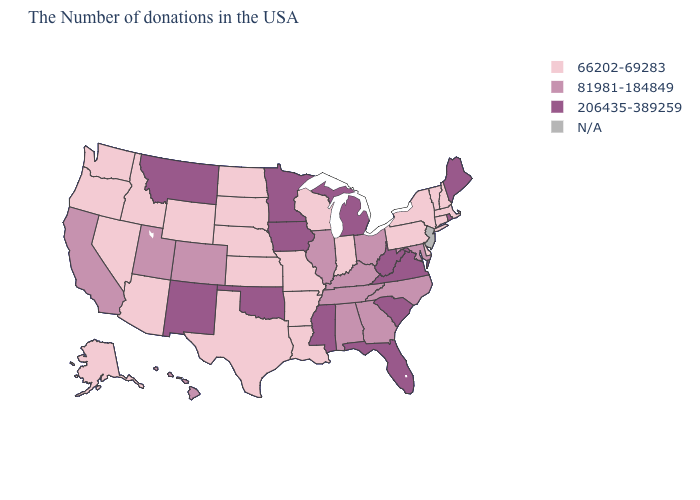Among the states that border Pennsylvania , does Ohio have the highest value?
Keep it brief. No. What is the lowest value in the USA?
Give a very brief answer. 66202-69283. What is the value of Michigan?
Answer briefly. 206435-389259. What is the value of Colorado?
Keep it brief. 81981-184849. Does Maryland have the lowest value in the South?
Write a very short answer. No. Name the states that have a value in the range 66202-69283?
Quick response, please. Massachusetts, New Hampshire, Vermont, Connecticut, New York, Delaware, Pennsylvania, Indiana, Wisconsin, Louisiana, Missouri, Arkansas, Kansas, Nebraska, Texas, South Dakota, North Dakota, Wyoming, Arizona, Idaho, Nevada, Washington, Oregon, Alaska. What is the value of Pennsylvania?
Write a very short answer. 66202-69283. Among the states that border North Carolina , does Tennessee have the highest value?
Short answer required. No. What is the lowest value in states that border New York?
Keep it brief. 66202-69283. Name the states that have a value in the range 206435-389259?
Keep it brief. Maine, Rhode Island, Virginia, South Carolina, West Virginia, Florida, Michigan, Mississippi, Minnesota, Iowa, Oklahoma, New Mexico, Montana. Name the states that have a value in the range 206435-389259?
Be succinct. Maine, Rhode Island, Virginia, South Carolina, West Virginia, Florida, Michigan, Mississippi, Minnesota, Iowa, Oklahoma, New Mexico, Montana. Does the first symbol in the legend represent the smallest category?
Write a very short answer. Yes. Name the states that have a value in the range 206435-389259?
Write a very short answer. Maine, Rhode Island, Virginia, South Carolina, West Virginia, Florida, Michigan, Mississippi, Minnesota, Iowa, Oklahoma, New Mexico, Montana. What is the highest value in the West ?
Keep it brief. 206435-389259. 